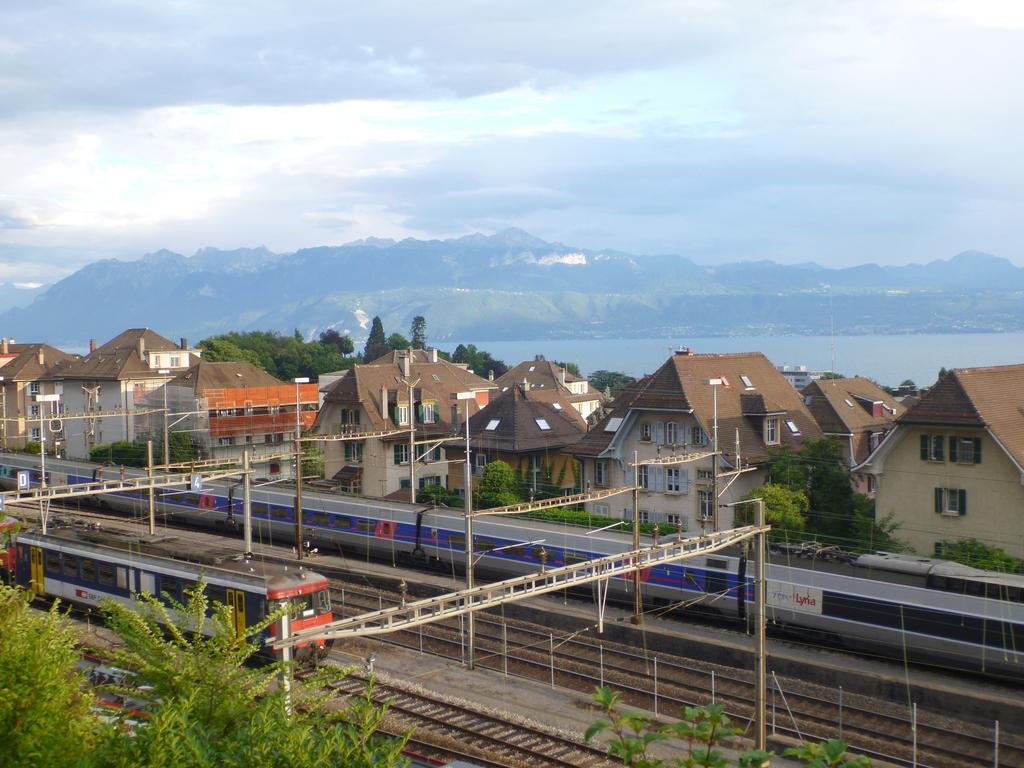Please provide a concise description of this image. In this image we can see two trains placed on the track. In the foreground of the image we can see a group of poles. In the center of the image we can see a group of buildings with roofs. In the background, we can see water, mountains and the cloudy sky. 